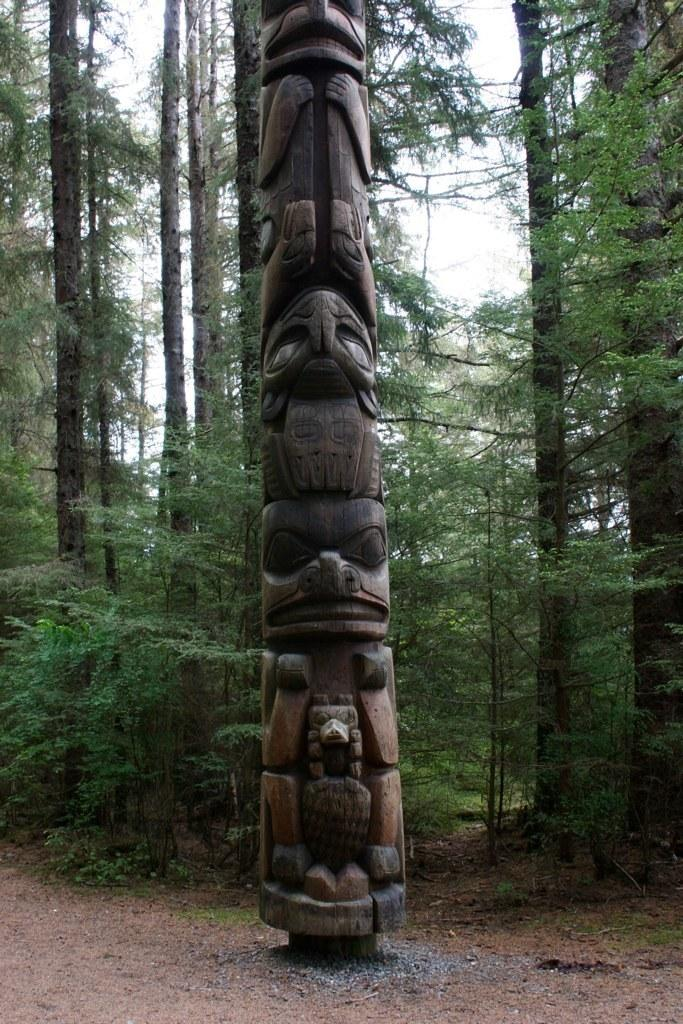What is the main subject of the image? There is an art piece on a wooden pole in the image. What can be seen beneath the art piece? The ground is visible in the image. What is visible in the background of the image? There are trees and the sky visible in the background of the image. What type of unit is being used to measure the design of the grass in the image? There is no grass present in the image, and therefore no unit of measurement is needed to measure its design. 